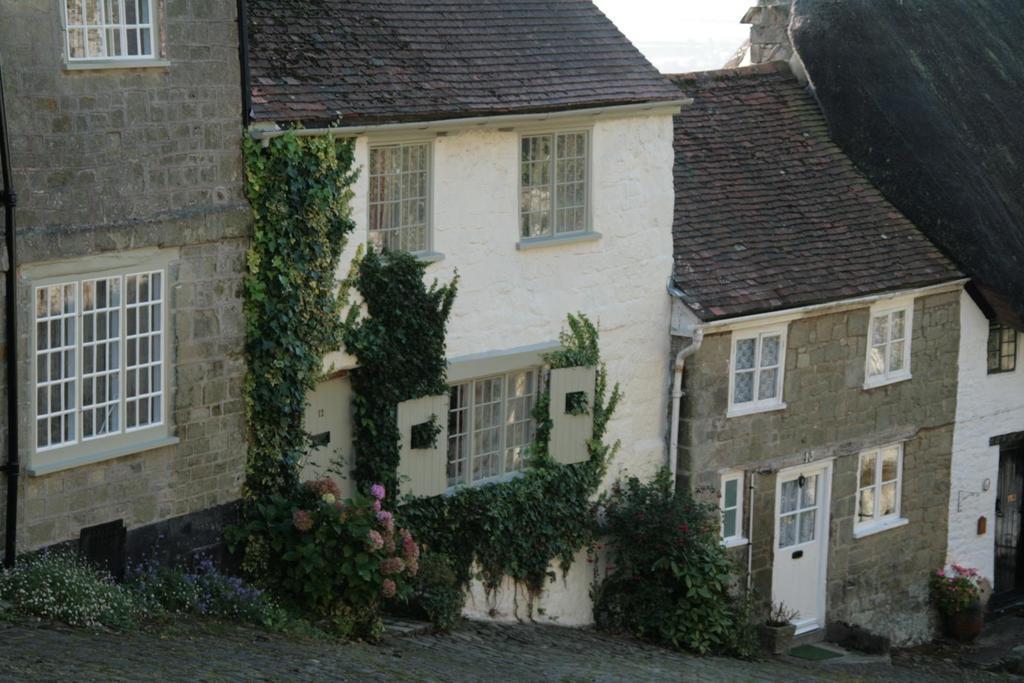Describe this image in one or two sentences. In this picture we can see buildings, at the bottom there are some plants and flowers, we can see windows of these buildings. 